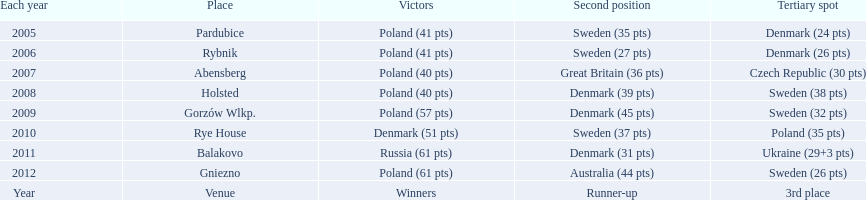After enjoying five consecutive victories at the team speedway junior world championship poland was finally unseated in what year? 2010. In that year, what teams placed first through third? Denmark (51 pts), Sweden (37 pts), Poland (35 pts). Which of those positions did poland specifically place in? 3rd place. 